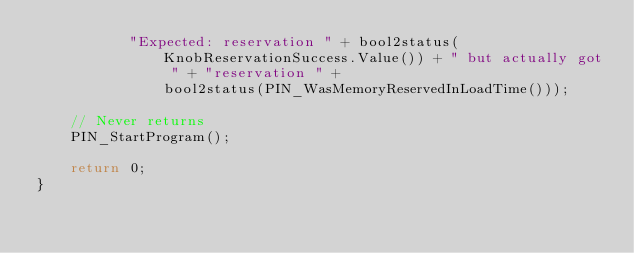Convert code to text. <code><loc_0><loc_0><loc_500><loc_500><_C++_>           "Expected: reservation " + bool2status(KnobReservationSuccess.Value()) + " but actually got " + "reservation " +
               bool2status(PIN_WasMemoryReservedInLoadTime()));

    // Never returns
    PIN_StartProgram();

    return 0;
}
</code> 